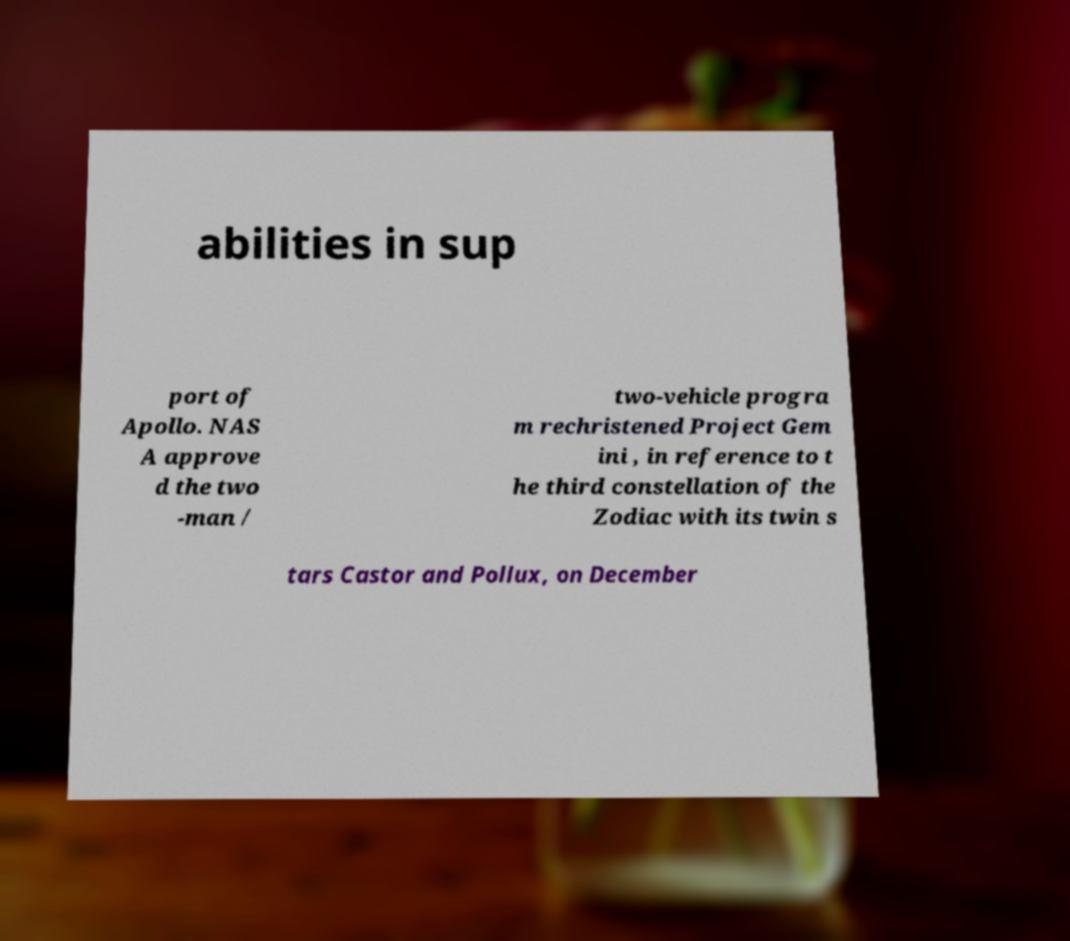Can you accurately transcribe the text from the provided image for me? abilities in sup port of Apollo. NAS A approve d the two -man / two-vehicle progra m rechristened Project Gem ini , in reference to t he third constellation of the Zodiac with its twin s tars Castor and Pollux, on December 